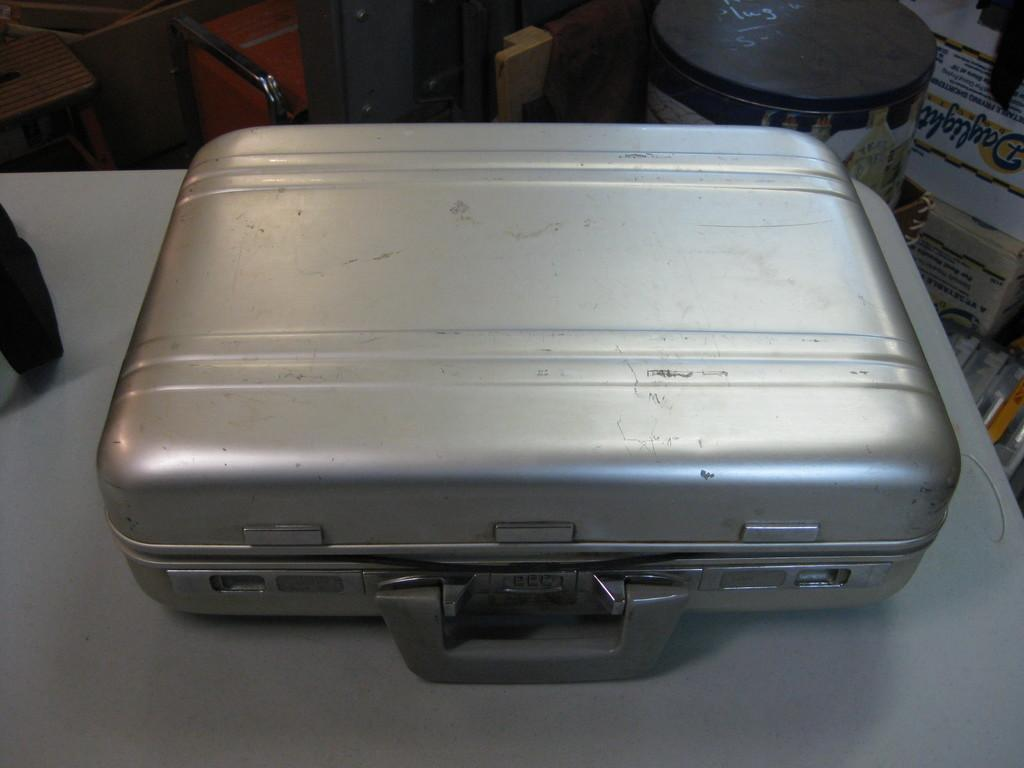What object can be seen on the table in the image? There is a briefcase on the table in the image. Where is the briefcase located in relation to the table? The briefcase is placed on the table. What can be seen in the background of the image? There is a box and a hoarding in the background of the image. How many apples are on the table in the image? There are no apples present in the image. What type of pollution can be seen in the image? There is no pollution visible in the image. 